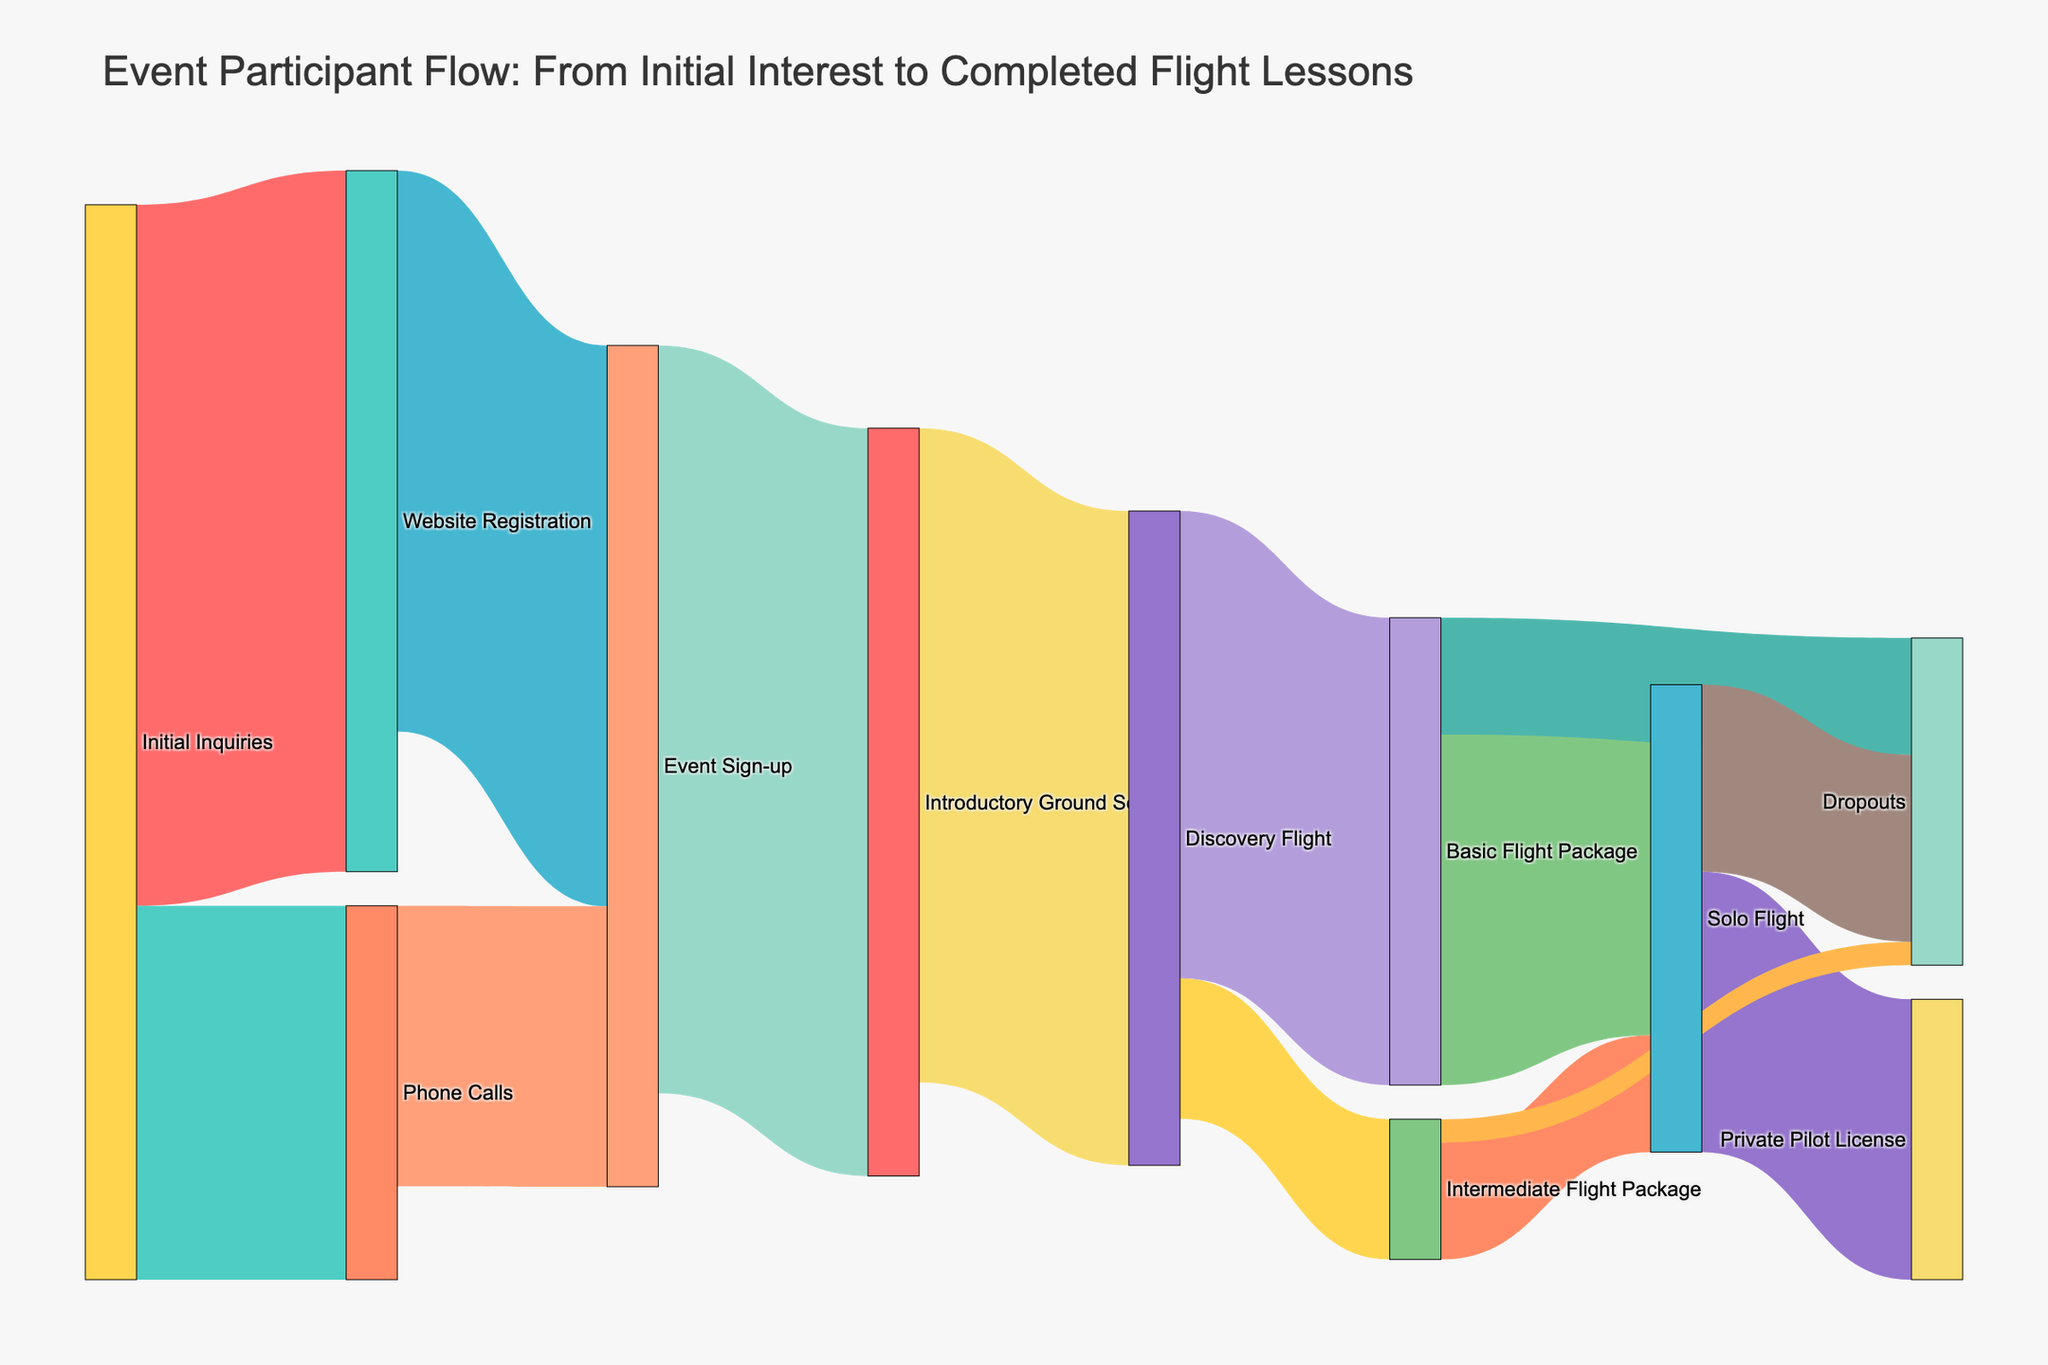what is the total number of participants who showed initial interest? To find the total number of participants who showed initial interest, sum the values of participants who made initial inquiries through either the website registration or phone calls. This includes 150 from "Website Registration" and 80 from "Phone Calls", giving us a total of 230 participants initially interested.
Answer: 230 how many participants transitioned from introductory ground school to discovery flight? Look at the flow from "Introductory Ground School" to "Discovery Flight" in the diagram. The value associated with this transition is 140.
Answer: 140 what is the total dropout rate for the participants? Sum the values of dropouts from all stages: "Basic Flight Package" (25), "Intermediate Flight Package" (5), and "Solo Flight" (40). The total dropouts are 25 + 5 + 40 = 70.
Answer: 70 which stage has the most significant dropout rate? By comparing dropout values at each stage: "Basic Flight Package" (25), "Intermediate Flight Package" (5), and "Solo Flight" (40), we can see that the highest dropout value is at the "Solo Flight" stage with 40 participants.
Answer: Solo Flight how many participants transition from event sign-up to introductory ground school? Look at the flow from "Event Sign-up" to "Introductory Ground School" in the diagram. The value associated with this transition is 160.
Answer: 160 what’s the ratio of participants who registered through the website versus those who called by phone? Compare the numbers for "Website Registration" (150) and "Phone Calls" (80). To find the ratio, divide 150 by 80, giving 150/80 = 1.875, which simplifies approximately to 1.88:1.
Answer: 1.88:1 what is the total number of participants who eventually took a solo flight? Sum the values of participants flowing into "Solo Flight" from both "Basic Flight Package" (75) and "Intermediate Flight Package" (25). 75 + 25 = 100 participants took a solo flight.
Answer: 100 how many participants proceed to gain a private pilot license from a solo flight? Look at the flow from "Solo Flight" to "Private Pilot License" in the diagram. The value associated with this transition is 60.
Answer: 60 how many participants moved from discovery flight directly to a basic flight package? The flow from "Discovery Flight" to "Basic Flight Package" shows 100 participants in the diagram.
Answer: 100 what is the proportion of participants that completed a discovery flight compared to those initially interested? Compare the total number who completed a discovery flight (140) with those initially interested (230). The proportion is 140/230 ≈ 0.61.
Answer: 0.61 